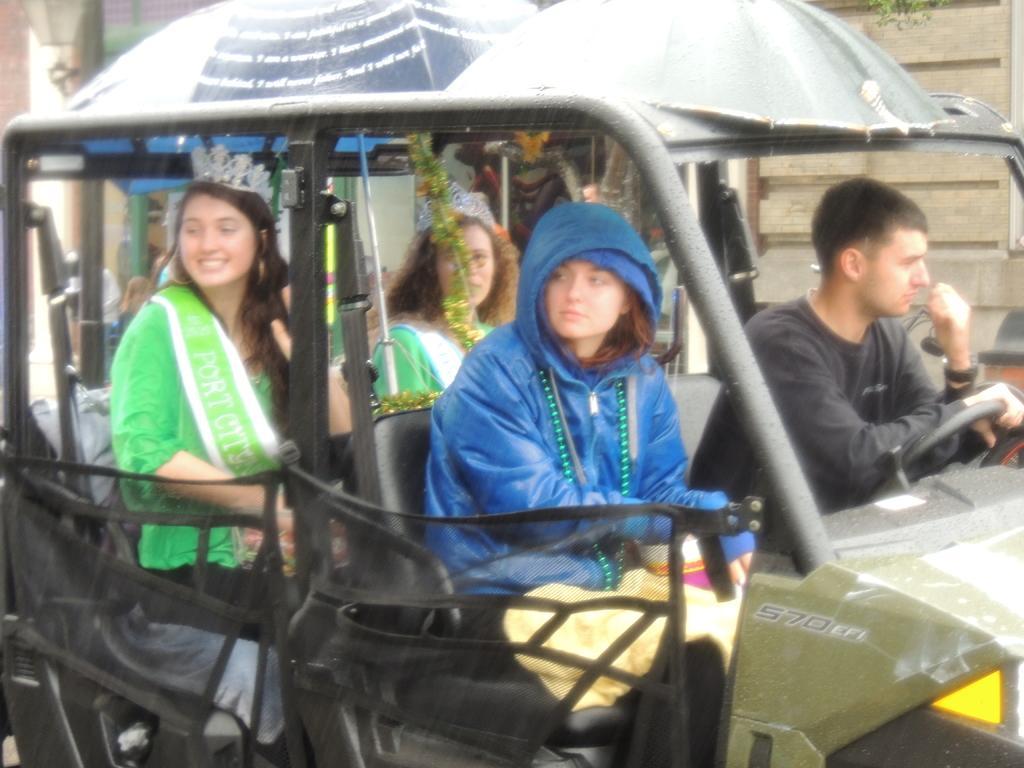Please provide a concise description of this image. In the image we can see there are people wearing clothes and two of them are wearing crown and they are sitting on the vehicle. Here we can see leaves and lamp. 